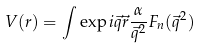Convert formula to latex. <formula><loc_0><loc_0><loc_500><loc_500>V ( r ) = \int \exp { i \vec { q } \vec { r } } \frac { \alpha } { \vec { q } ^ { 2 } } F _ { n } ( \vec { q } ^ { 2 } )</formula> 